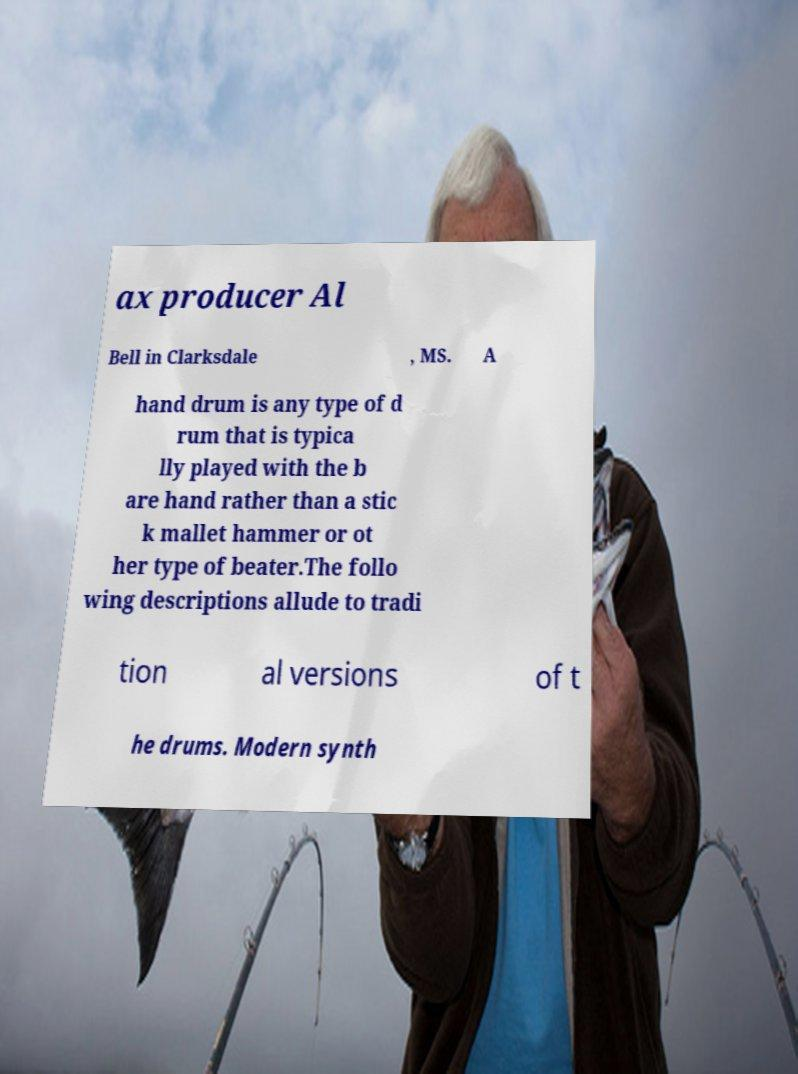Can you read and provide the text displayed in the image?This photo seems to have some interesting text. Can you extract and type it out for me? ax producer Al Bell in Clarksdale , MS. A hand drum is any type of d rum that is typica lly played with the b are hand rather than a stic k mallet hammer or ot her type of beater.The follo wing descriptions allude to tradi tion al versions of t he drums. Modern synth 